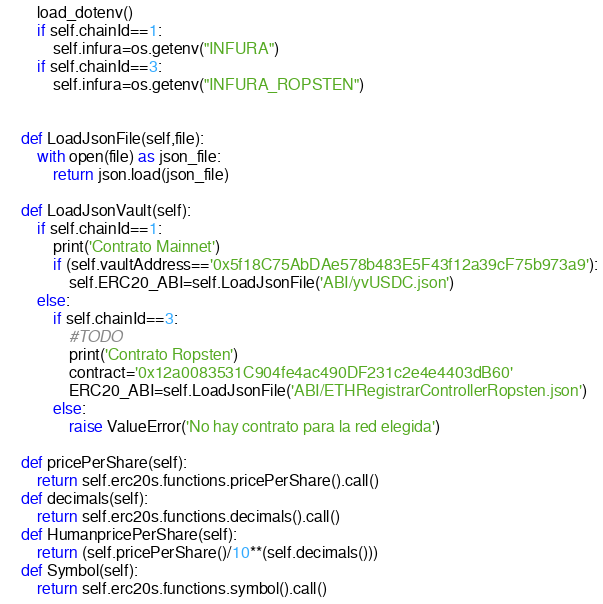Convert code to text. <code><loc_0><loc_0><loc_500><loc_500><_Python_>        load_dotenv()        
        if self.chainId==1:
            self.infura=os.getenv("INFURA")
        if self.chainId==3:
            self.infura=os.getenv("INFURA_ROPSTEN")            


    def LoadJsonFile(self,file):
        with open(file) as json_file:
            return json.load(json_file)

    def LoadJsonVault(self):
        if self.chainId==1:
            print('Contrato Mainnet')
            if (self.vaultAddress=='0x5f18C75AbDAe578b483E5F43f12a39cF75b973a9'):
                self.ERC20_ABI=self.LoadJsonFile('ABI/yvUSDC.json')
        else:
            if self.chainId==3:
                #TODO
                print('Contrato Ropsten')
                contract='0x12a0083531C904fe4ac490DF231c2e4e4403dB60'
                ERC20_ABI=self.LoadJsonFile('ABI/ETHRegistrarControllerRopsten.json')
            else:
                raise ValueError('No hay contrato para la red elegida')

    def pricePerShare(self):
        return self.erc20s.functions.pricePerShare().call()
    def decimals(self):
        return self.erc20s.functions.decimals().call()
    def HumanpricePerShare(self):
        return (self.pricePerShare()/10**(self.decimals()))      
    def Symbol(self):
        return self.erc20s.functions.symbol().call()  












</code> 